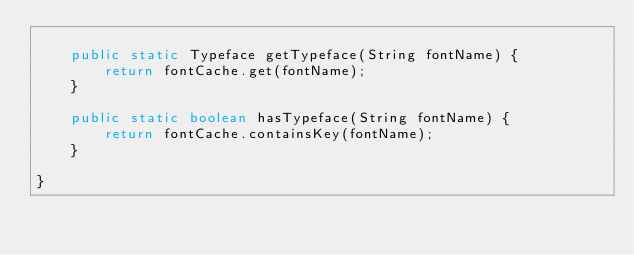Convert code to text. <code><loc_0><loc_0><loc_500><loc_500><_Java_>
    public static Typeface getTypeface(String fontName) {
        return fontCache.get(fontName);
    }

    public static boolean hasTypeface(String fontName) {
        return fontCache.containsKey(fontName);
    }

}</code> 